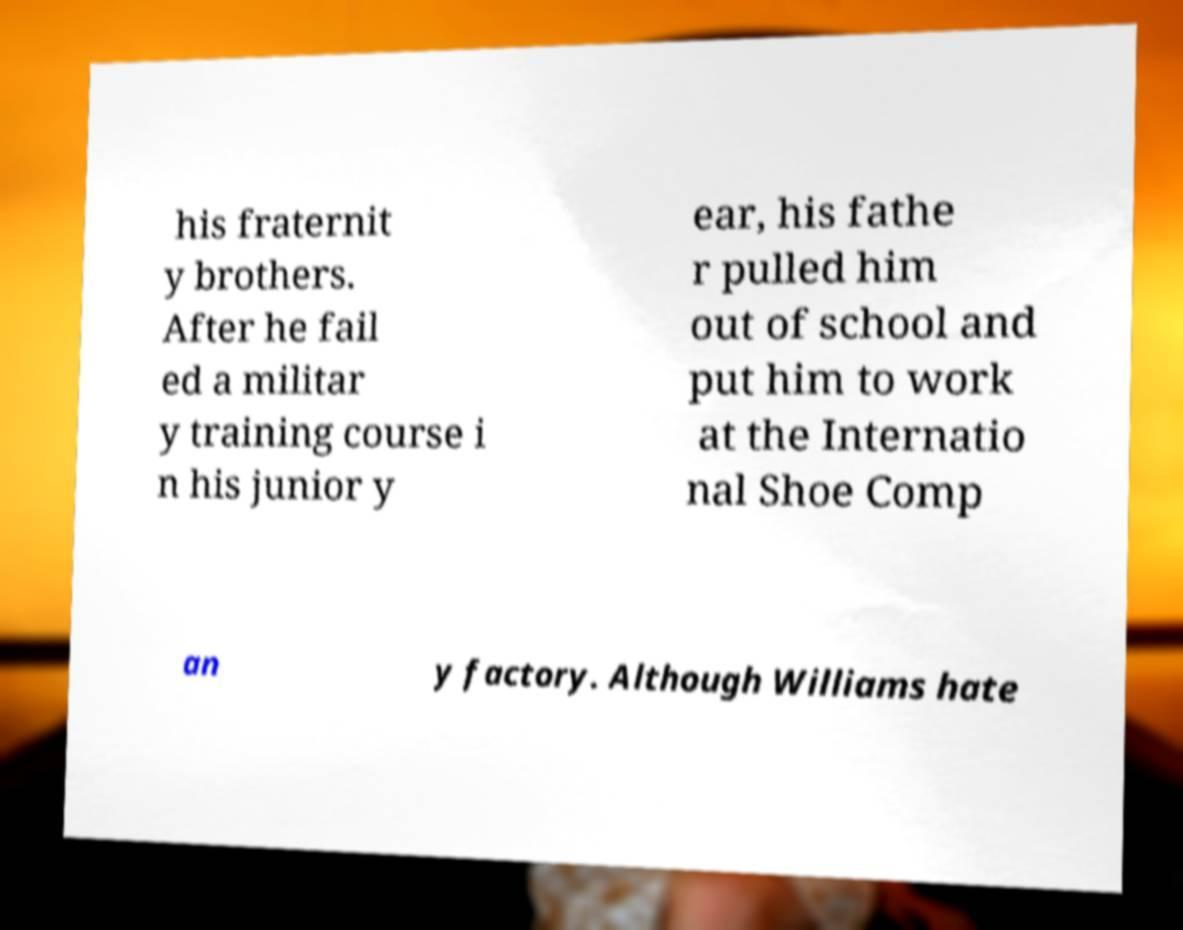I need the written content from this picture converted into text. Can you do that? his fraternit y brothers. After he fail ed a militar y training course i n his junior y ear, his fathe r pulled him out of school and put him to work at the Internatio nal Shoe Comp an y factory. Although Williams hate 